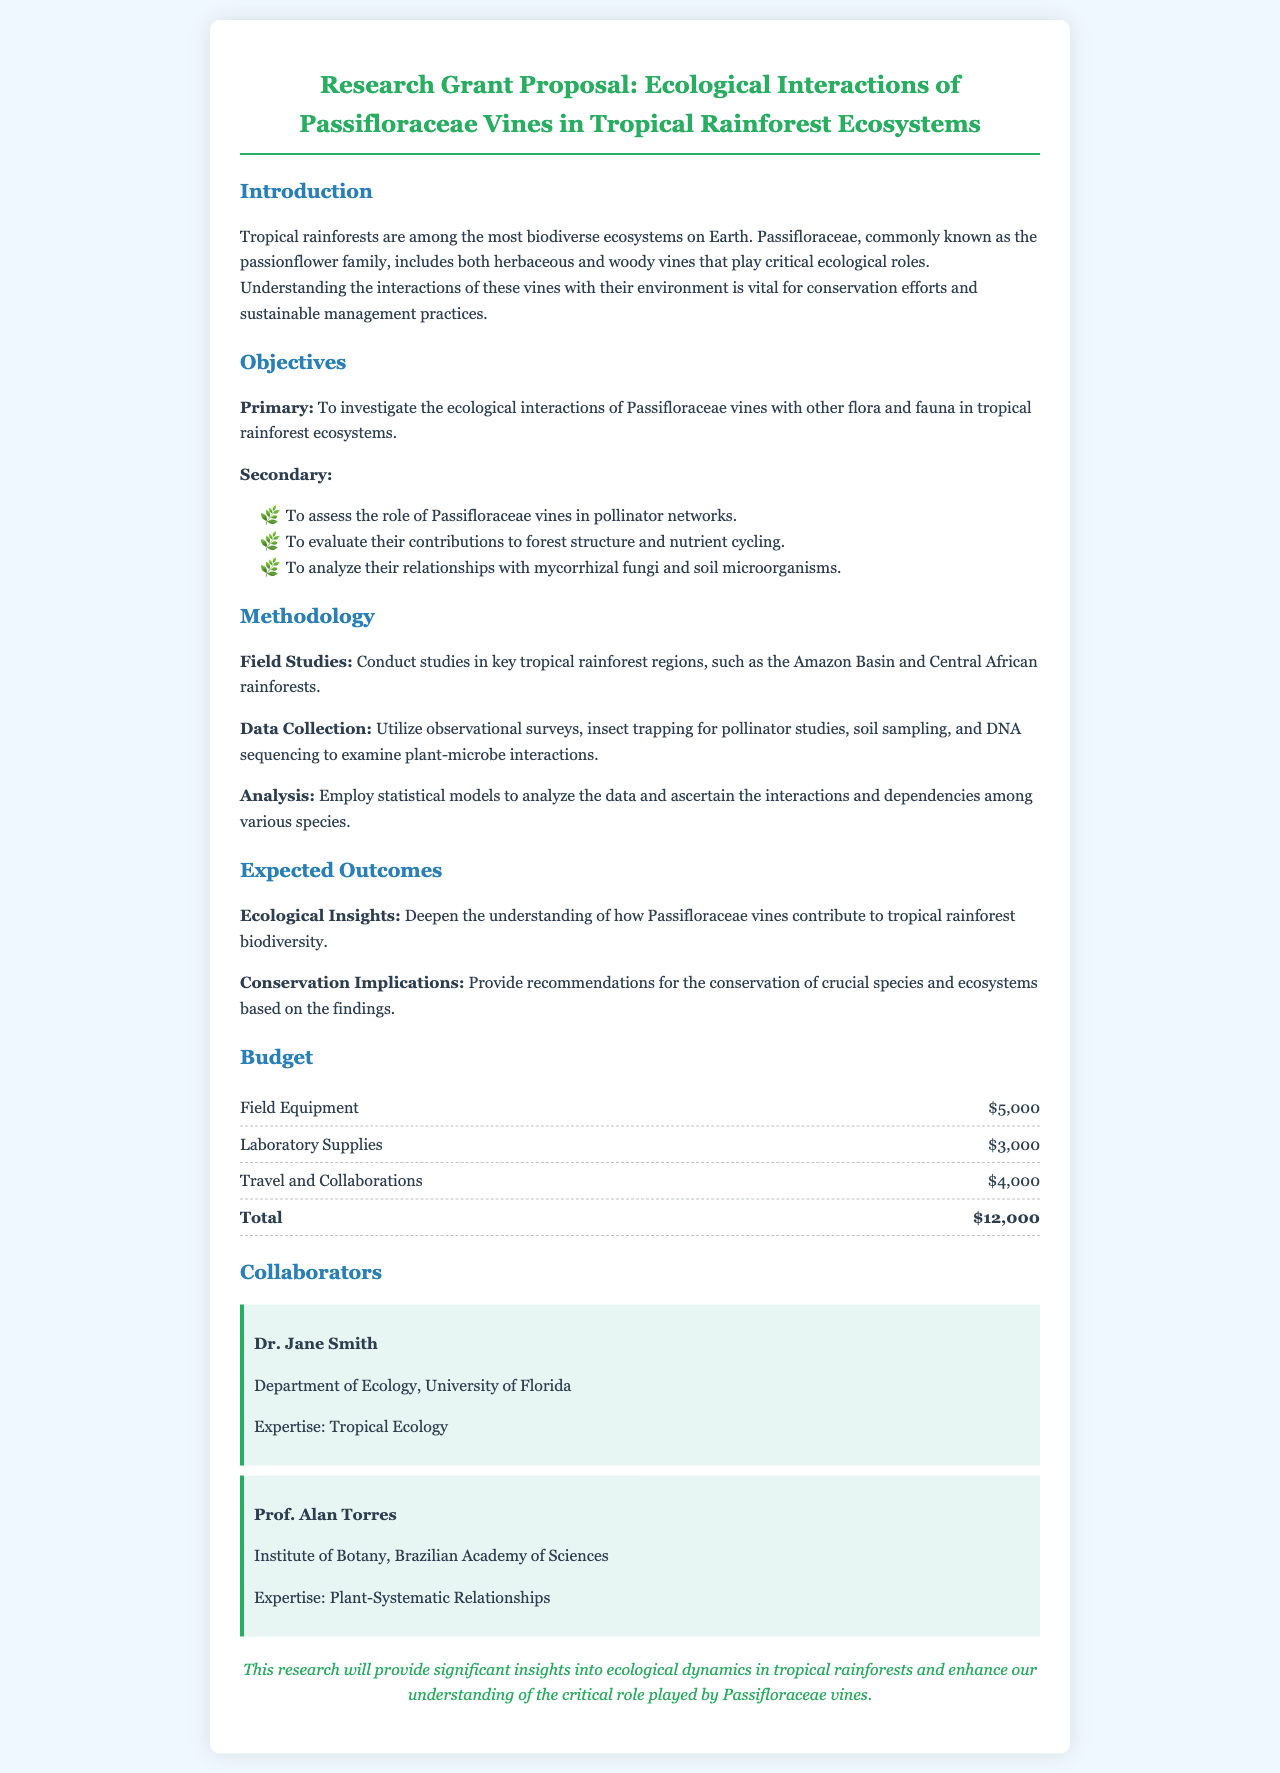what is the primary objective of the research? The primary objective is to investigate the ecological interactions of Passifloraceae vines with other flora and fauna in tropical rainforest ecosystems.
Answer: To investigate the ecological interactions of Passifloraceae vines with other flora and fauna in tropical rainforest ecosystems who are the collaborators listed in the proposal? The proposal lists Dr. Jane Smith and Prof. Alan Torres as collaborators.
Answer: Dr. Jane Smith and Prof. Alan Torres what is the total budget for the research? The total budget is the sum of all budget items listed in the document, which is $5,000 + $3,000 + $4,000.
Answer: $12,000 what method will be used for data collection? The data collection methods include observational surveys, insect trapping, soil sampling, and DNA sequencing.
Answer: Observational surveys, insect trapping, soil sampling, and DNA sequencing what is one expected outcome of the study? One expected outcome is to deepen the understanding of how Passifloraceae vines contribute to tropical rainforest biodiversity.
Answer: To deepen the understanding of how Passifloraceae vines contribute to tropical rainforest biodiversity how many secondary objectives are mentioned in the proposal? There are three secondary objectives mentioned in the proposal.
Answer: Three what is the role of Passifloraceae vines in the ecosystem according to the proposal? The proposal states that Passifloraceae vines play critical ecological roles in tropical rainforests.
Answer: Critical ecological roles 